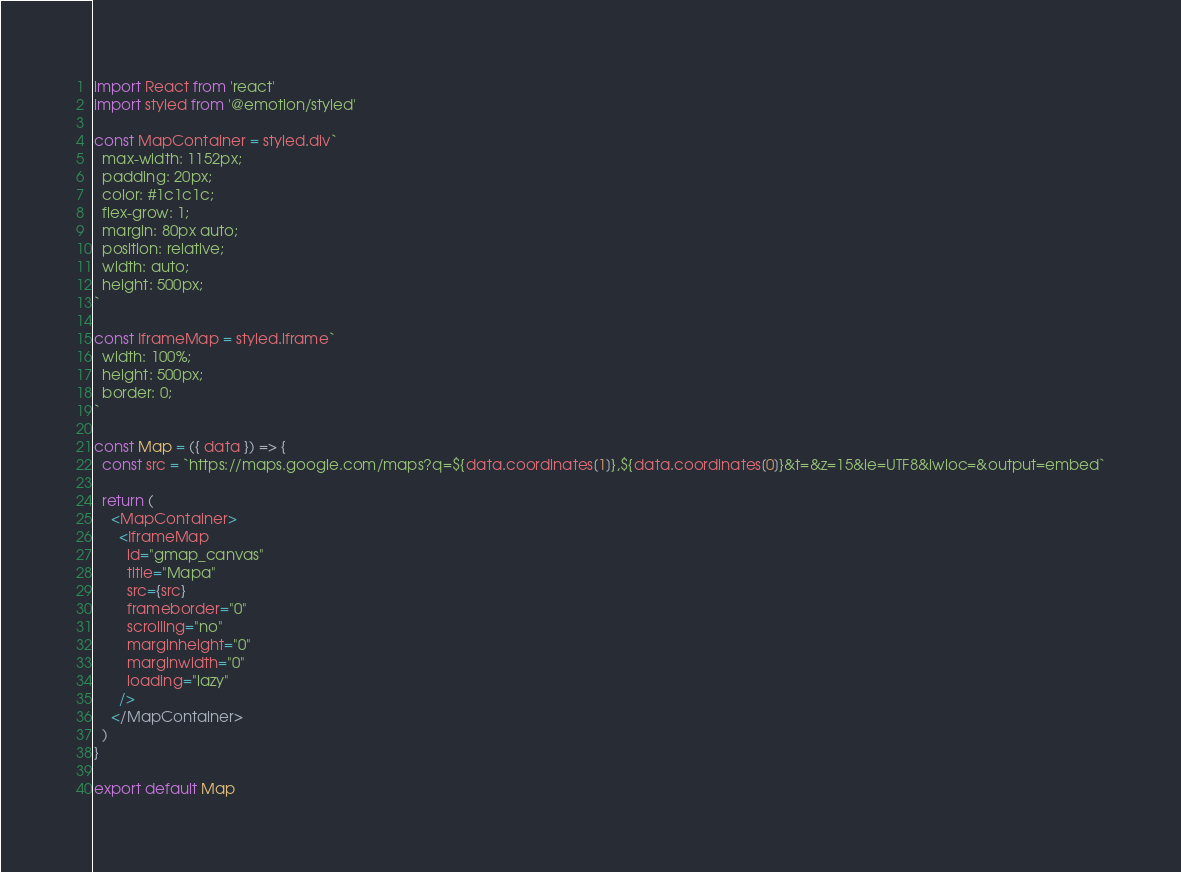Convert code to text. <code><loc_0><loc_0><loc_500><loc_500><_JavaScript_>import React from 'react'
import styled from '@emotion/styled'

const MapContainer = styled.div`
  max-width: 1152px;
  padding: 20px;
  color: #1c1c1c;
  flex-grow: 1;
  margin: 80px auto;
  position: relative;
  width: auto;
  height: 500px;
`

const IframeMap = styled.iframe`
  width: 100%;
  height: 500px;
  border: 0;
`

const Map = ({ data }) => {
  const src = `https://maps.google.com/maps?q=${data.coordinates[1]},${data.coordinates[0]}&t=&z=15&ie=UTF8&iwloc=&output=embed`

  return (
    <MapContainer>
      <IframeMap
        id="gmap_canvas"
        title="Mapa"
        src={src}
        frameborder="0"
        scrolling="no"
        marginheight="0"
        marginwidth="0"
        loading="lazy"
      />
    </MapContainer>
  )
}

export default Map
</code> 